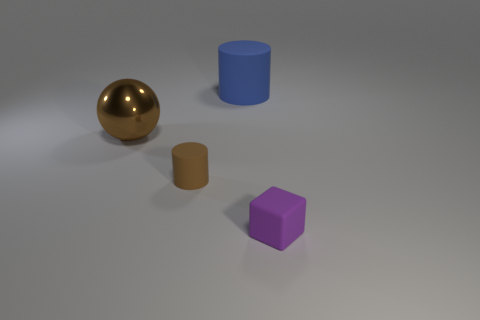Add 1 small purple matte spheres. How many objects exist? 5 Subtract all balls. How many objects are left? 3 Add 2 tiny purple matte objects. How many tiny purple matte objects are left? 3 Add 4 small brown shiny cylinders. How many small brown shiny cylinders exist? 4 Subtract 0 cyan spheres. How many objects are left? 4 Subtract all brown matte cylinders. Subtract all small metal blocks. How many objects are left? 3 